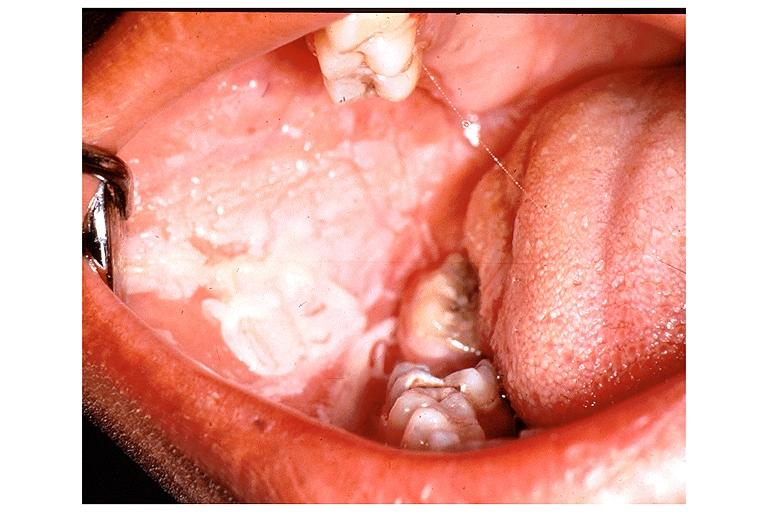s soft tissue present?
Answer the question using a single word or phrase. No 